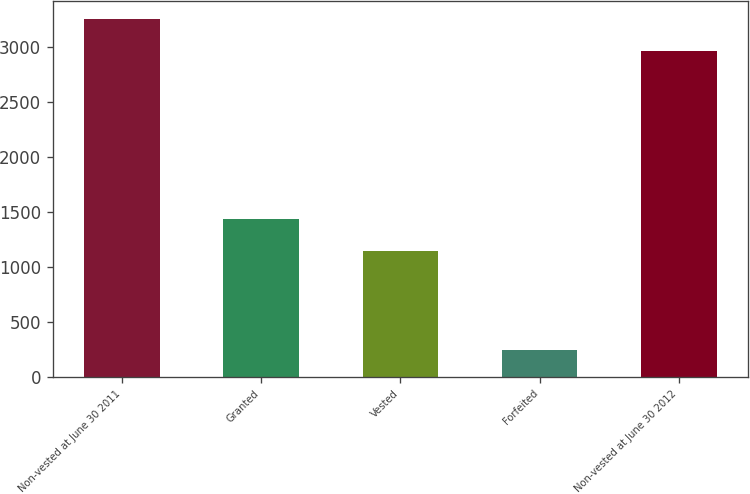Convert chart to OTSL. <chart><loc_0><loc_0><loc_500><loc_500><bar_chart><fcel>Non-vested at June 30 2011<fcel>Granted<fcel>Vested<fcel>Forfeited<fcel>Non-vested at June 30 2012<nl><fcel>3256.9<fcel>1434.9<fcel>1148<fcel>246<fcel>2970<nl></chart> 